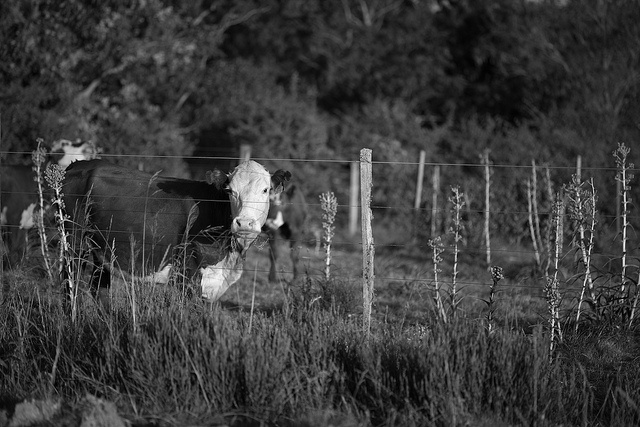Describe the objects in this image and their specific colors. I can see a cow in black, gray, darkgray, and lightgray tones in this image. 